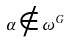<formula> <loc_0><loc_0><loc_500><loc_500>\alpha \notin \omega ^ { G }</formula> 